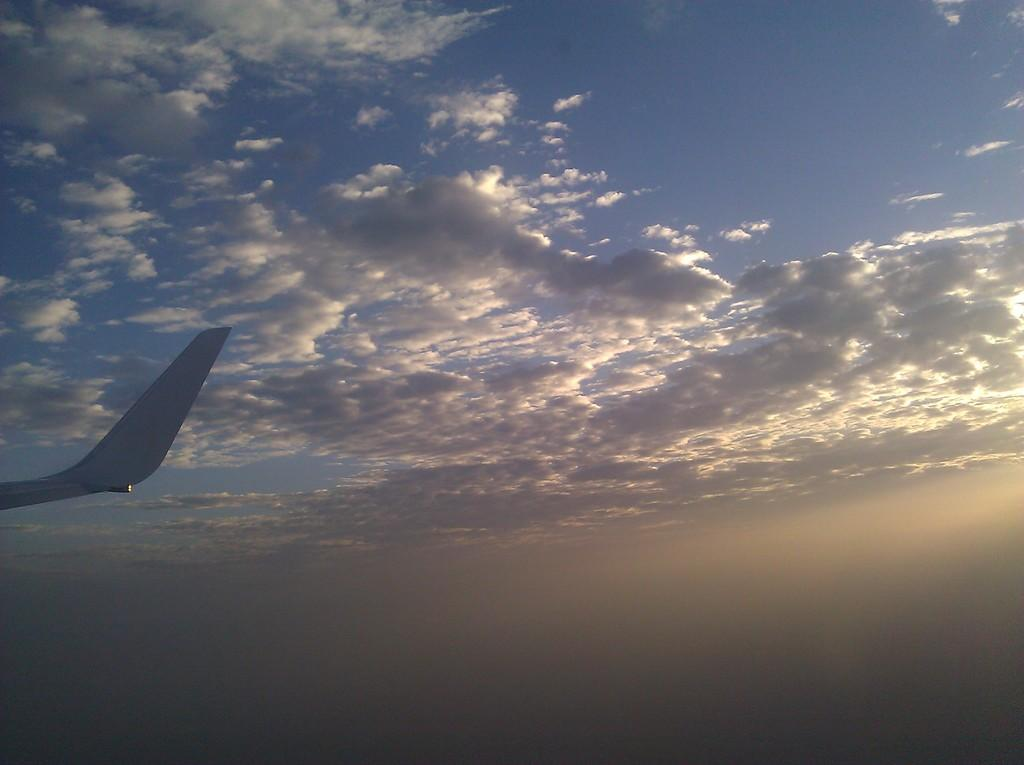What is the main subject of the image? The main subject of the image is a plane wing. What can be seen in the background of the image? There are clouds in the sky in the image. What type of stocking is being used to hold the plane wing in the image? There is no stocking present in the image, and the plane wing is not being held by any object. 